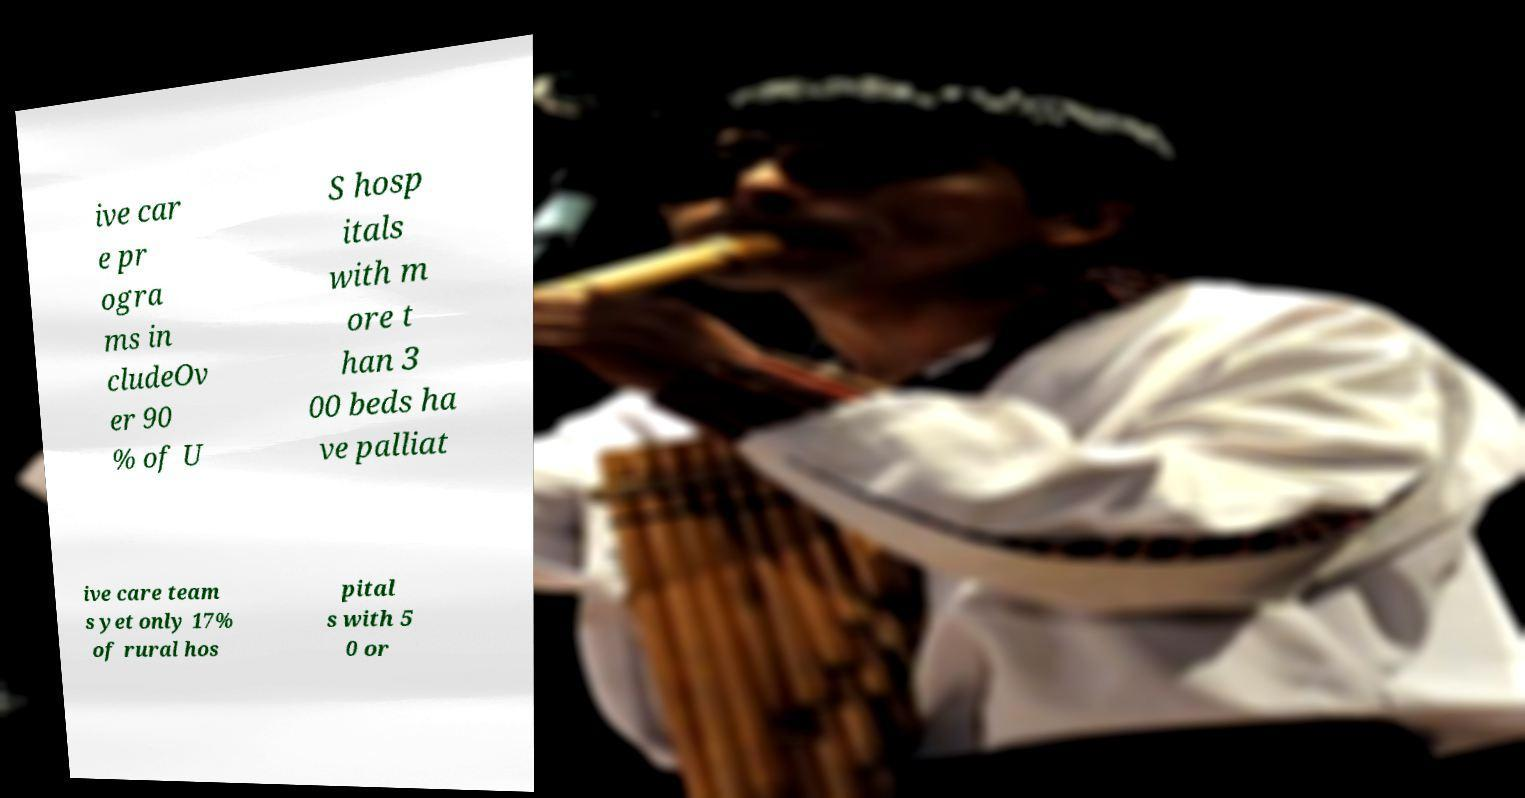For documentation purposes, I need the text within this image transcribed. Could you provide that? ive car e pr ogra ms in cludeOv er 90 % of U S hosp itals with m ore t han 3 00 beds ha ve palliat ive care team s yet only 17% of rural hos pital s with 5 0 or 